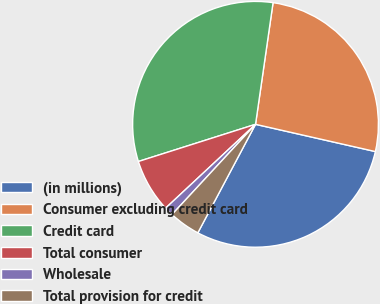Convert chart to OTSL. <chart><loc_0><loc_0><loc_500><loc_500><pie_chart><fcel>(in millions)<fcel>Consumer excluding credit card<fcel>Credit card<fcel>Total consumer<fcel>Wholesale<fcel>Total provision for credit<nl><fcel>29.22%<fcel>26.28%<fcel>32.17%<fcel>7.05%<fcel>1.17%<fcel>4.11%<nl></chart> 